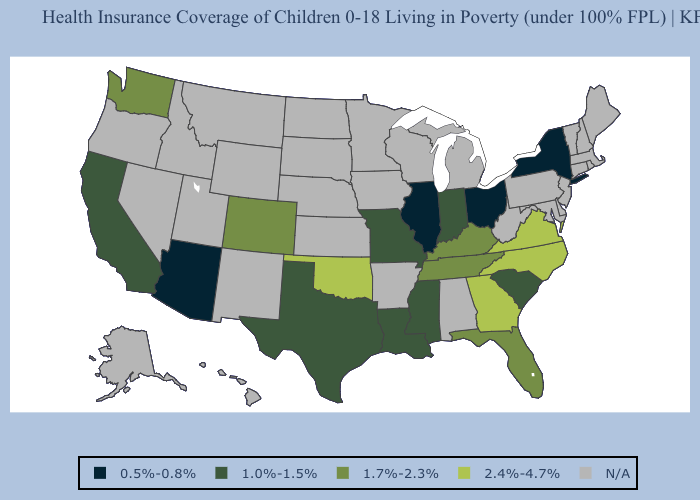What is the highest value in the USA?
Answer briefly. 2.4%-4.7%. What is the lowest value in the Northeast?
Write a very short answer. 0.5%-0.8%. Among the states that border North Carolina , which have the lowest value?
Answer briefly. South Carolina. Does North Carolina have the highest value in the USA?
Quick response, please. Yes. Does Virginia have the lowest value in the USA?
Give a very brief answer. No. What is the highest value in the MidWest ?
Write a very short answer. 1.0%-1.5%. What is the highest value in the South ?
Keep it brief. 2.4%-4.7%. Does the map have missing data?
Write a very short answer. Yes. Name the states that have a value in the range 0.5%-0.8%?
Be succinct. Arizona, Illinois, New York, Ohio. What is the lowest value in the West?
Give a very brief answer. 0.5%-0.8%. Which states have the lowest value in the USA?
Write a very short answer. Arizona, Illinois, New York, Ohio. What is the value of South Dakota?
Be succinct. N/A. 